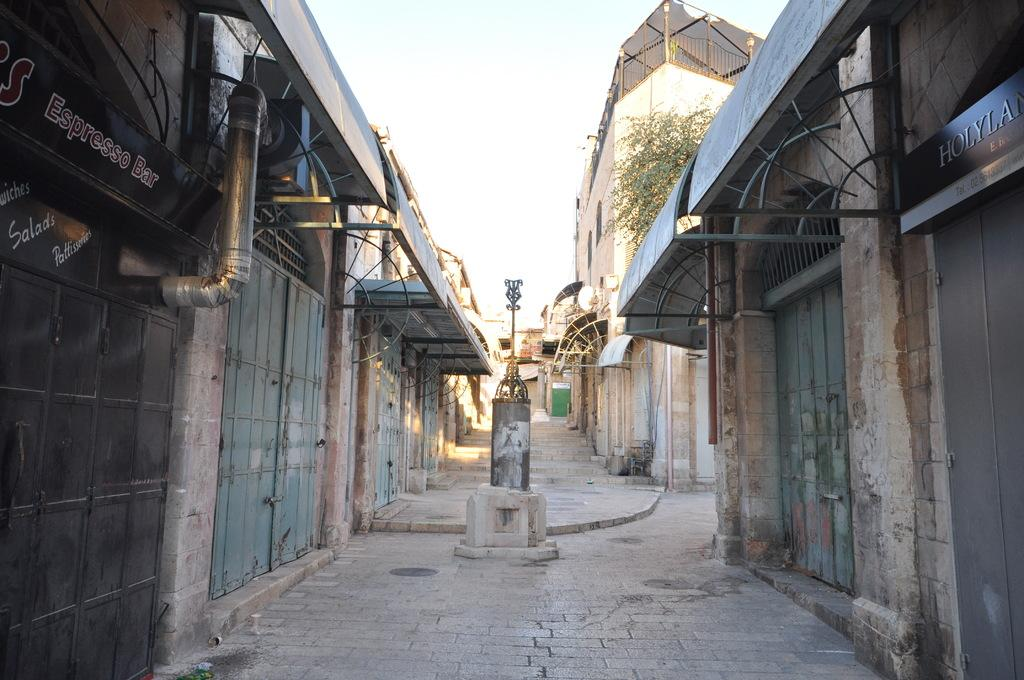What type of structures can be seen in the image? There are doors and walls visible in the image. What type of advertisement or signage is present in the image? There are hoardings in the image. What type of architectural feature is present in the image? There are rods in the image. What part of the natural environment is visible in the image? The sky is visible in the image. What type of vegetation is present in the image? There is a tree in the image. What type of barrier is present in the image? There are grills in the image. Can you see any blood on the walls in the image? There is no blood visible on the walls in the image. How many lakes are present in the image? There are no lakes present in the image. How many trees are visible in the image? The image only shows one tree. 